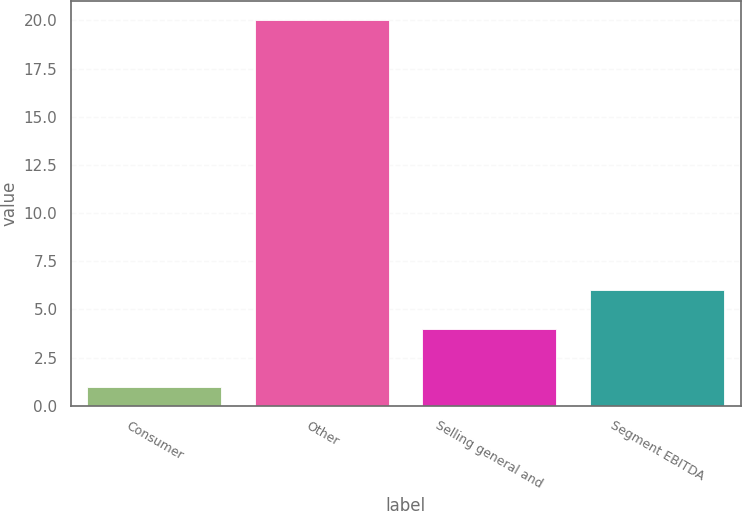Convert chart to OTSL. <chart><loc_0><loc_0><loc_500><loc_500><bar_chart><fcel>Consumer<fcel>Other<fcel>Selling general and<fcel>Segment EBITDA<nl><fcel>1<fcel>20<fcel>4<fcel>6<nl></chart> 